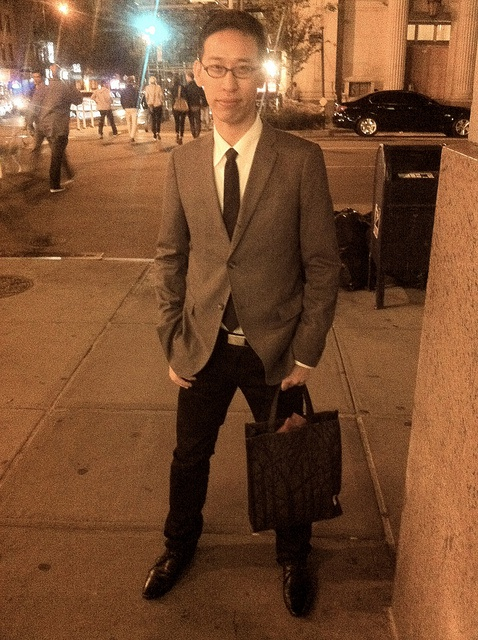Describe the objects in this image and their specific colors. I can see people in maroon, black, and brown tones, handbag in maroon, black, and brown tones, car in maroon, black, and brown tones, people in maroon, gray, brown, and black tones, and tie in maroon, black, and gray tones in this image. 